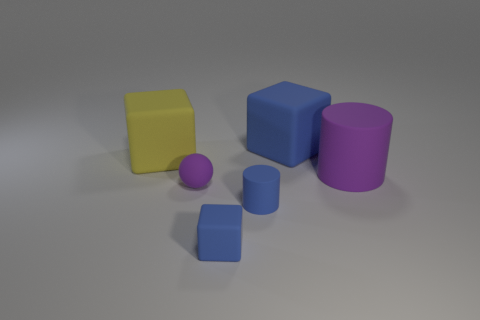What material is the cylinder that is in front of the matte object that is on the right side of the blue object behind the purple cylinder made of?
Your answer should be compact. Rubber. What shape is the large yellow thing that is the same material as the large purple thing?
Ensure brevity in your answer.  Cube. There is a purple matte object that is behind the small purple thing; are there any purple matte spheres behind it?
Ensure brevity in your answer.  No. The yellow cube is what size?
Keep it short and to the point. Large. What number of objects are big purple matte cylinders or small blue matte things?
Give a very brief answer. 3. Is the blue cube behind the large yellow matte thing made of the same material as the object that is to the left of the small purple rubber object?
Your answer should be compact. Yes. What is the color of the large cylinder that is made of the same material as the tiny blue block?
Your answer should be very brief. Purple. What number of purple matte objects have the same size as the blue cylinder?
Ensure brevity in your answer.  1. How many other things are there of the same color as the small cube?
Your answer should be compact. 2. Is the shape of the big rubber object to the left of the tiny purple matte thing the same as the large matte thing behind the yellow cube?
Offer a terse response. Yes. 